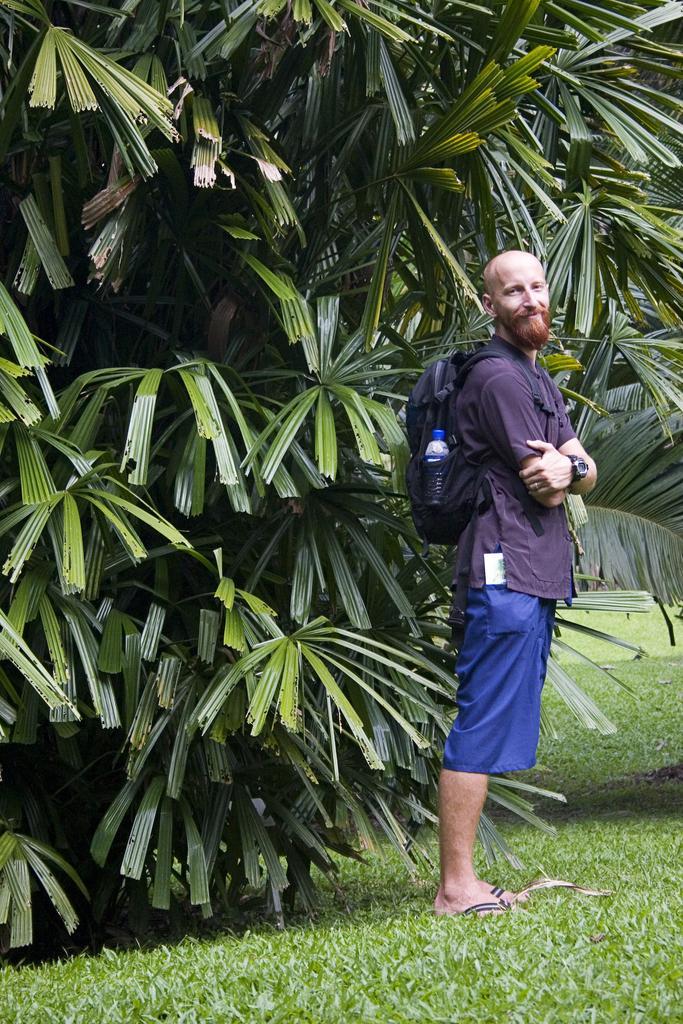In one or two sentences, can you explain what this image depicts? In this image we can see a person wearing backpack standing on the ground. In the background we can see trees. 